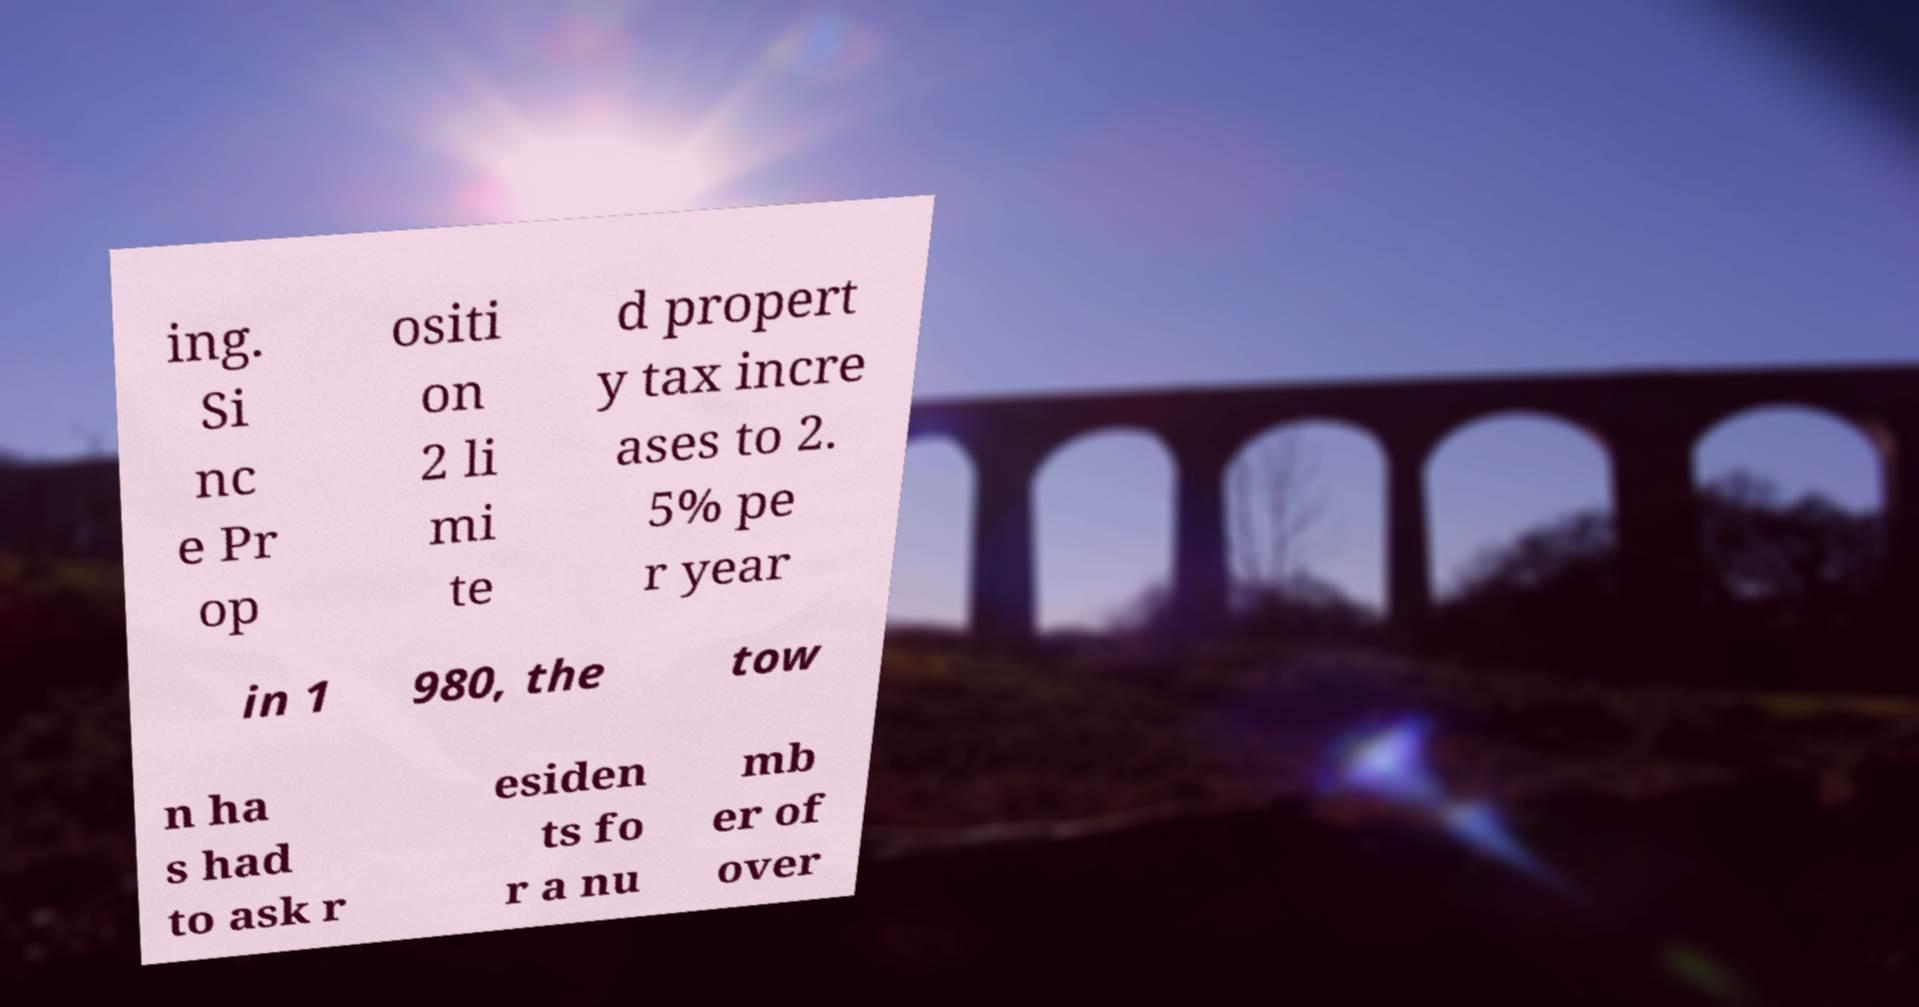Can you accurately transcribe the text from the provided image for me? ing. Si nc e Pr op ositi on 2 li mi te d propert y tax incre ases to 2. 5% pe r year in 1 980, the tow n ha s had to ask r esiden ts fo r a nu mb er of over 